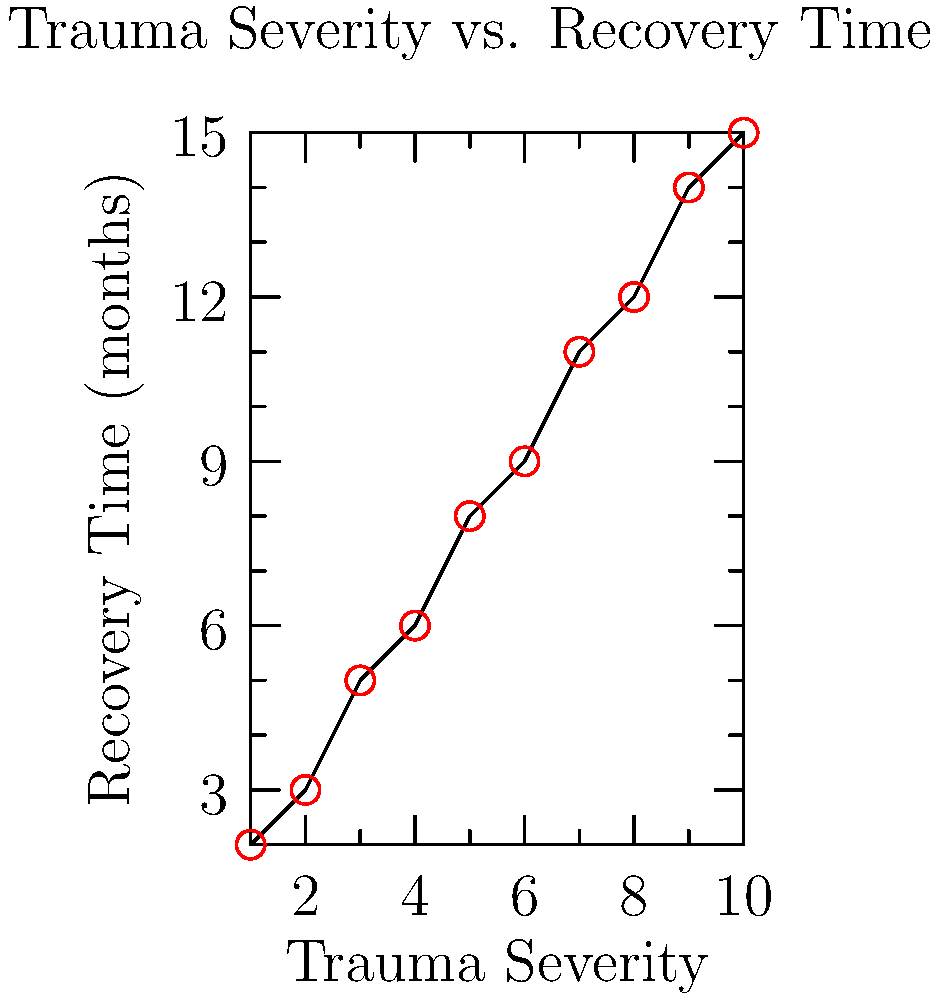As a trauma specialist, you're analyzing the relationship between trauma severity and recovery time. Based on the scatter plot, what type of correlation exists between these variables, and how might this information influence your approach to treatment planning for trauma survivors? To determine the correlation between trauma severity and recovery time, we need to analyze the scatter plot:

1. Observe the overall pattern: The points generally move from the bottom-left to the top-right of the graph.

2. Assess the direction: As trauma severity increases, recovery time also tends to increase. This indicates a positive correlation.

3. Evaluate the strength: The points form a relatively tight, linear pattern with little scatter. This suggests a strong correlation.

4. Determine the type of correlation: The relationship appears to be linear, as the points roughly follow a straight line.

5. Quantify the correlation: Without calculating the exact correlation coefficient, we can visually estimate it to be strong and positive, likely above 0.8.

6. Clinical implications:
   a. Expect longer recovery times for more severe traumas.
   b. Develop tiered treatment plans based on trauma severity.
   c. Allocate resources and support proportionally to trauma severity.
   d. Set realistic expectations for recovery timelines with patients.
   e. Consider early interventions for severe traumas to potentially reduce recovery time.

7. Treatment planning approach:
   a. Use trauma severity as a predictor of required treatment duration.
   b. Implement more intensive therapies for severe traumas.
   c. Prepare for longer-term support and follow-up for severe cases.
   d. Develop strategies to potentially accelerate recovery in severe cases.
   e. Educate patients and families about the relationship between severity and recovery time.

This analysis allows for evidence-based, personalized treatment planning that accounts for the strong positive correlation between trauma severity and recovery time.
Answer: Strong positive linear correlation; tailor treatment intensity and duration to trauma severity. 